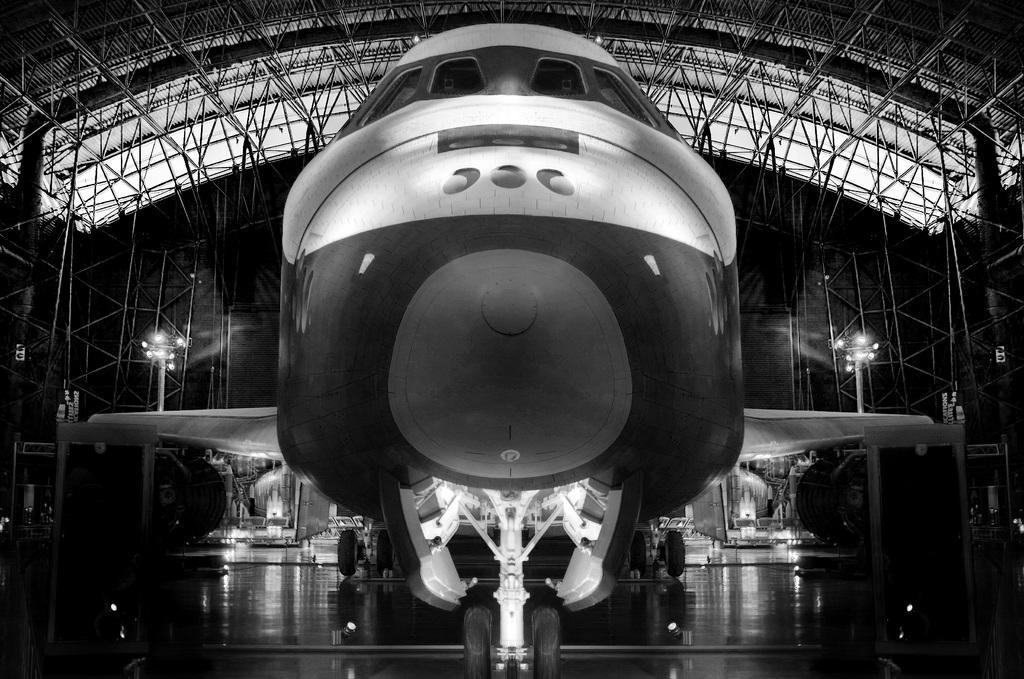Can you describe this image briefly? In a given image I can see a lights, shed, fence and some other objects. 